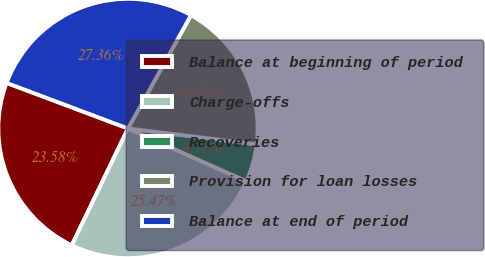Convert chart to OTSL. <chart><loc_0><loc_0><loc_500><loc_500><pie_chart><fcel>Balance at beginning of period<fcel>Charge-offs<fcel>Recoveries<fcel>Provision for loan losses<fcel>Balance at end of period<nl><fcel>23.58%<fcel>25.47%<fcel>4.72%<fcel>18.87%<fcel>27.36%<nl></chart> 